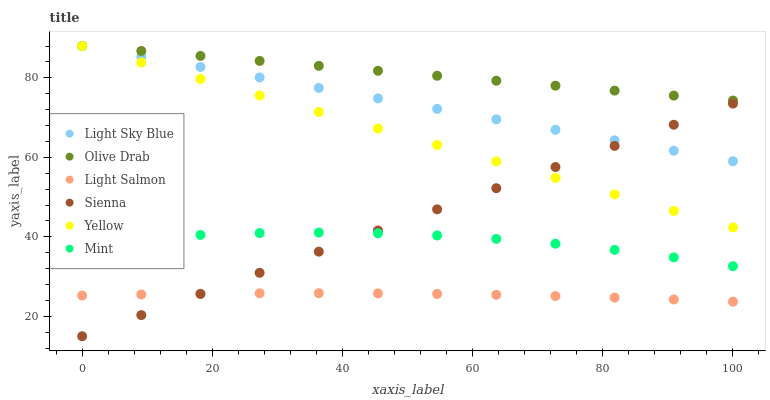Does Light Salmon have the minimum area under the curve?
Answer yes or no. Yes. Does Olive Drab have the maximum area under the curve?
Answer yes or no. Yes. Does Yellow have the minimum area under the curve?
Answer yes or no. No. Does Yellow have the maximum area under the curve?
Answer yes or no. No. Is Olive Drab the smoothest?
Answer yes or no. Yes. Is Mint the roughest?
Answer yes or no. Yes. Is Yellow the smoothest?
Answer yes or no. No. Is Yellow the roughest?
Answer yes or no. No. Does Sienna have the lowest value?
Answer yes or no. Yes. Does Yellow have the lowest value?
Answer yes or no. No. Does Olive Drab have the highest value?
Answer yes or no. Yes. Does Sienna have the highest value?
Answer yes or no. No. Is Mint less than Olive Drab?
Answer yes or no. Yes. Is Yellow greater than Mint?
Answer yes or no. Yes. Does Light Sky Blue intersect Yellow?
Answer yes or no. Yes. Is Light Sky Blue less than Yellow?
Answer yes or no. No. Is Light Sky Blue greater than Yellow?
Answer yes or no. No. Does Mint intersect Olive Drab?
Answer yes or no. No. 